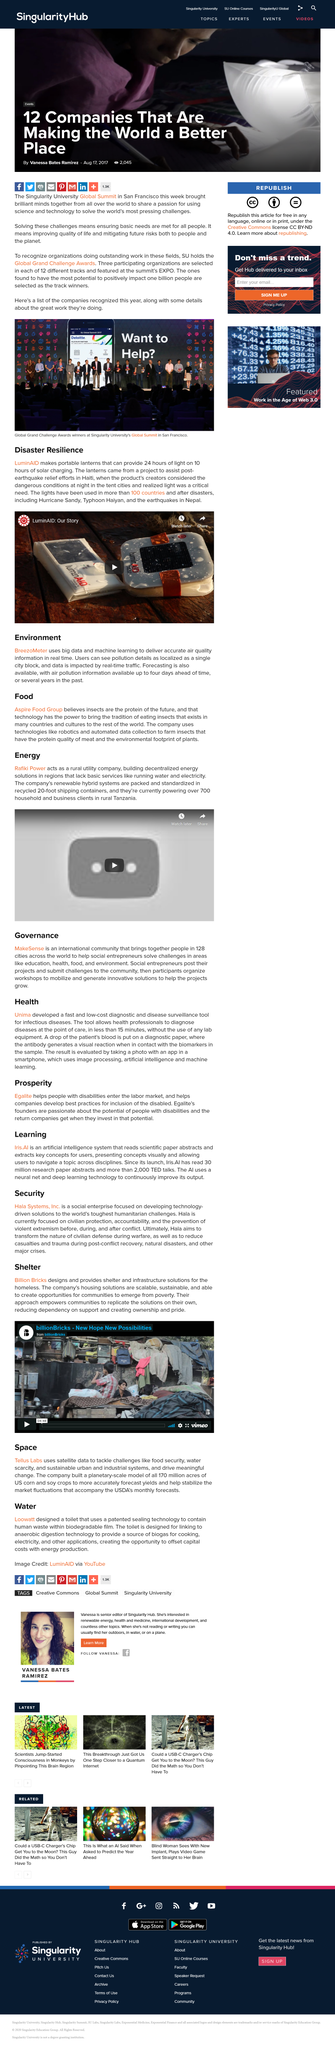Indicate a few pertinent items in this graphic. The creation of the LuminAID device was motivated by the realization of the devastating impact of natural disasters, as evidenced by the 2010 Haiti earthquake. In the aftermath of this disaster, it became clear that access to reliable sources of light was a critical need for recovery efforts. This realization led to the development of the LuminAID device, which has since become an essential tool for disaster response and recovery. LuminAID has been used in various disasters, apart from the Haiti's Earthquake, such as Hurricane Sandy, Typhoon Haiyan, and the earthquakes in Nepal, to provide light and emergency shelter to those in need. Billion Bricks is a company that specializes in designing and providing shelter and infrastructure solutions for individuals and communities experiencing homelessness. Egalite is a program that assists individuals with disabilities in entering the workforce and helps companies develop inclusive policies and practices for the disabled. LuminAID produces portable lanterns that are capable of providing 24 hours of light on 10 hours of solar charging. 